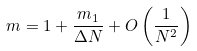<formula> <loc_0><loc_0><loc_500><loc_500>m = 1 + \frac { m _ { 1 } } { \Delta N } + O \left ( \frac { 1 } { N ^ { 2 } } \right )</formula> 